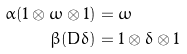<formula> <loc_0><loc_0><loc_500><loc_500>\alpha ( 1 \otimes \omega \otimes 1 ) & = \omega \\ \beta ( D \delta ) & = 1 \otimes \delta \otimes 1</formula> 